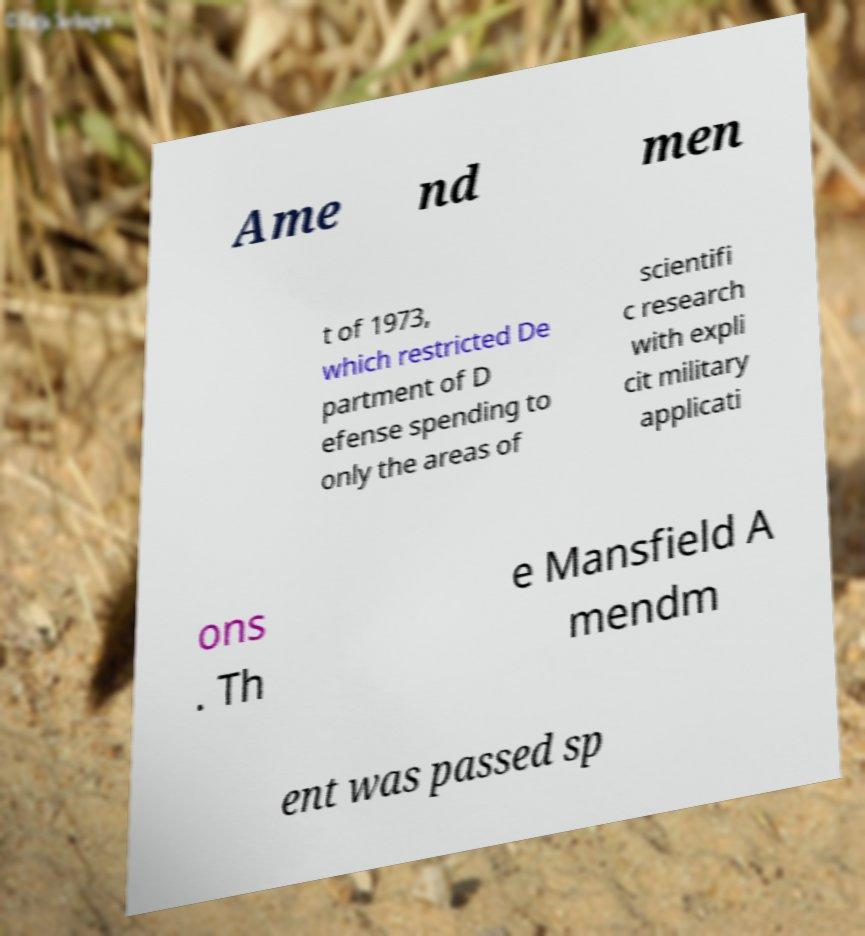Could you extract and type out the text from this image? Ame nd men t of 1973, which restricted De partment of D efense spending to only the areas of scientifi c research with expli cit military applicati ons . Th e Mansfield A mendm ent was passed sp 